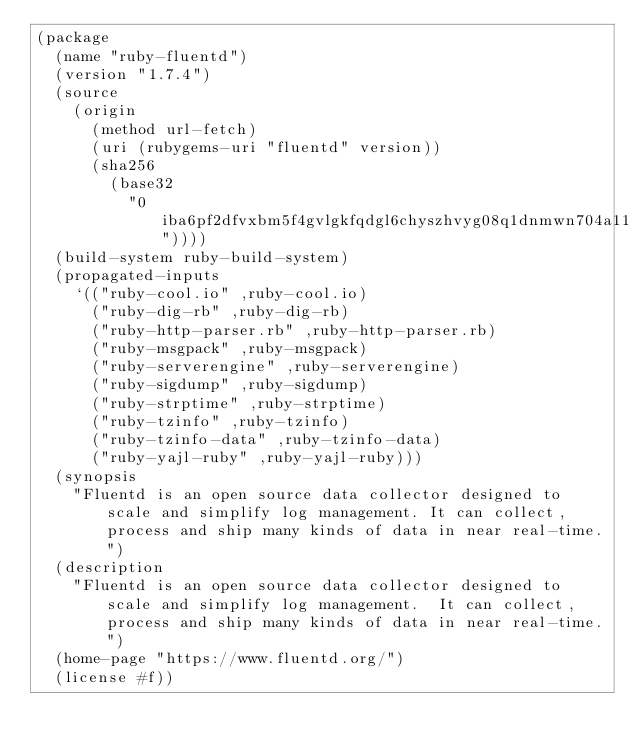Convert code to text. <code><loc_0><loc_0><loc_500><loc_500><_Scheme_>(package
  (name "ruby-fluentd")
  (version "1.7.4")
  (source
    (origin
      (method url-fetch)
      (uri (rubygems-uri "fluentd" version))
      (sha256
        (base32
          "0iba6pf2dfvxbm5f4gvlgkfqdgl6chyszhvyg08q1dnmwn704a11"))))
  (build-system ruby-build-system)
  (propagated-inputs
    `(("ruby-cool.io" ,ruby-cool.io)
      ("ruby-dig-rb" ,ruby-dig-rb)
      ("ruby-http-parser.rb" ,ruby-http-parser.rb)
      ("ruby-msgpack" ,ruby-msgpack)
      ("ruby-serverengine" ,ruby-serverengine)
      ("ruby-sigdump" ,ruby-sigdump)
      ("ruby-strptime" ,ruby-strptime)
      ("ruby-tzinfo" ,ruby-tzinfo)
      ("ruby-tzinfo-data" ,ruby-tzinfo-data)
      ("ruby-yajl-ruby" ,ruby-yajl-ruby)))
  (synopsis
    "Fluentd is an open source data collector designed to scale and simplify log management. It can collect, process and ship many kinds of data in near real-time.")
  (description
    "Fluentd is an open source data collector designed to scale and simplify log management.  It can collect, process and ship many kinds of data in near real-time.")
  (home-page "https://www.fluentd.org/")
  (license #f))
</code> 